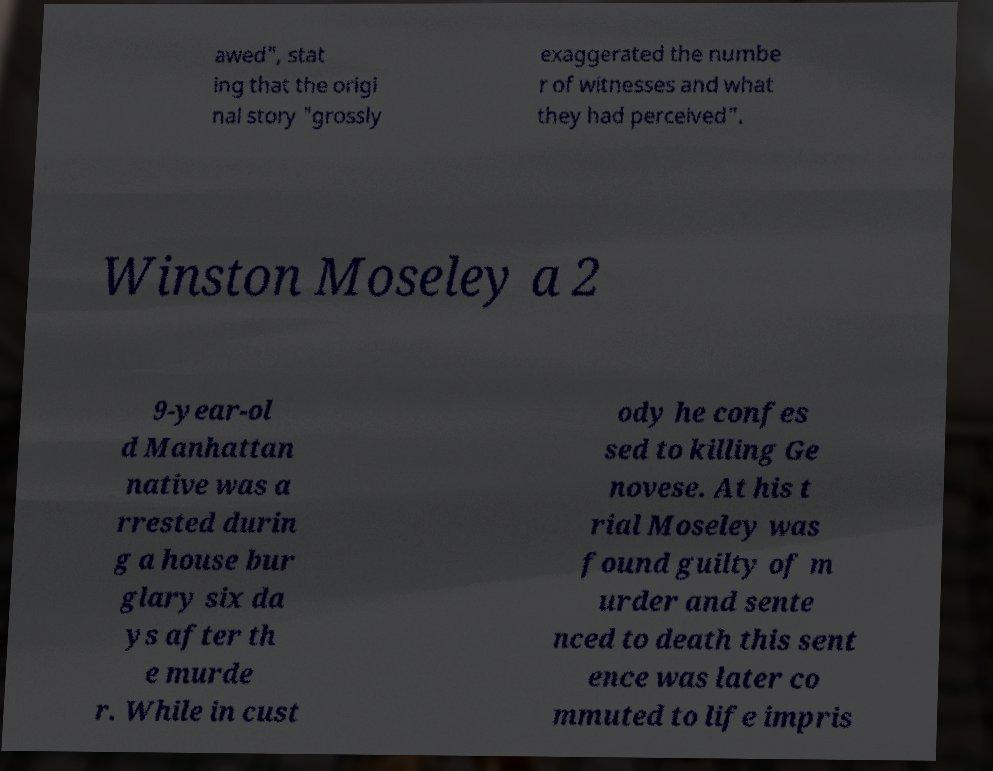Can you read and provide the text displayed in the image?This photo seems to have some interesting text. Can you extract and type it out for me? awed", stat ing that the origi nal story "grossly exaggerated the numbe r of witnesses and what they had perceived". Winston Moseley a 2 9-year-ol d Manhattan native was a rrested durin g a house bur glary six da ys after th e murde r. While in cust ody he confes sed to killing Ge novese. At his t rial Moseley was found guilty of m urder and sente nced to death this sent ence was later co mmuted to life impris 